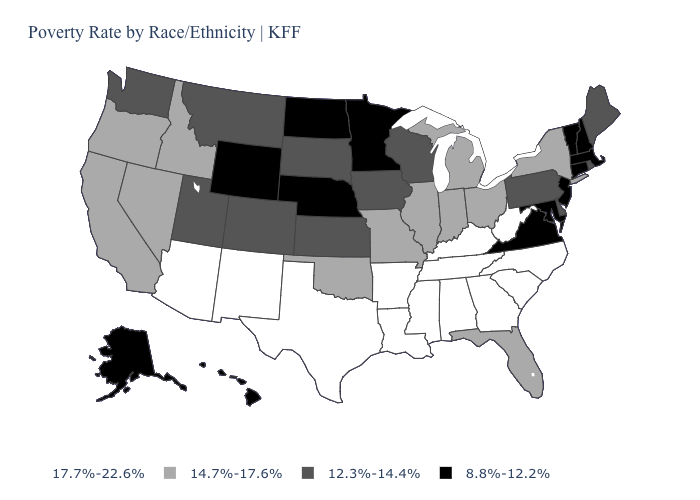What is the value of Arizona?
Write a very short answer. 17.7%-22.6%. What is the lowest value in the USA?
Be succinct. 8.8%-12.2%. What is the highest value in the USA?
Quick response, please. 17.7%-22.6%. What is the value of Nevada?
Give a very brief answer. 14.7%-17.6%. What is the value of Wisconsin?
Be succinct. 12.3%-14.4%. What is the highest value in the USA?
Quick response, please. 17.7%-22.6%. Does California have a higher value than Pennsylvania?
Answer briefly. Yes. Which states have the highest value in the USA?
Answer briefly. Alabama, Arizona, Arkansas, Georgia, Kentucky, Louisiana, Mississippi, New Mexico, North Carolina, South Carolina, Tennessee, Texas, West Virginia. Does Virginia have the highest value in the USA?
Quick response, please. No. What is the highest value in the Northeast ?
Quick response, please. 14.7%-17.6%. What is the value of Mississippi?
Answer briefly. 17.7%-22.6%. What is the value of North Carolina?
Keep it brief. 17.7%-22.6%. Does New Mexico have the highest value in the West?
Answer briefly. Yes. Which states have the highest value in the USA?
Write a very short answer. Alabama, Arizona, Arkansas, Georgia, Kentucky, Louisiana, Mississippi, New Mexico, North Carolina, South Carolina, Tennessee, Texas, West Virginia. 